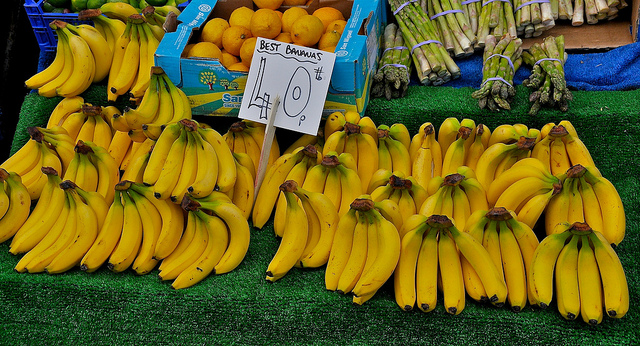Please transcribe the text in this image. BEST BANANAS 40 p Sa 